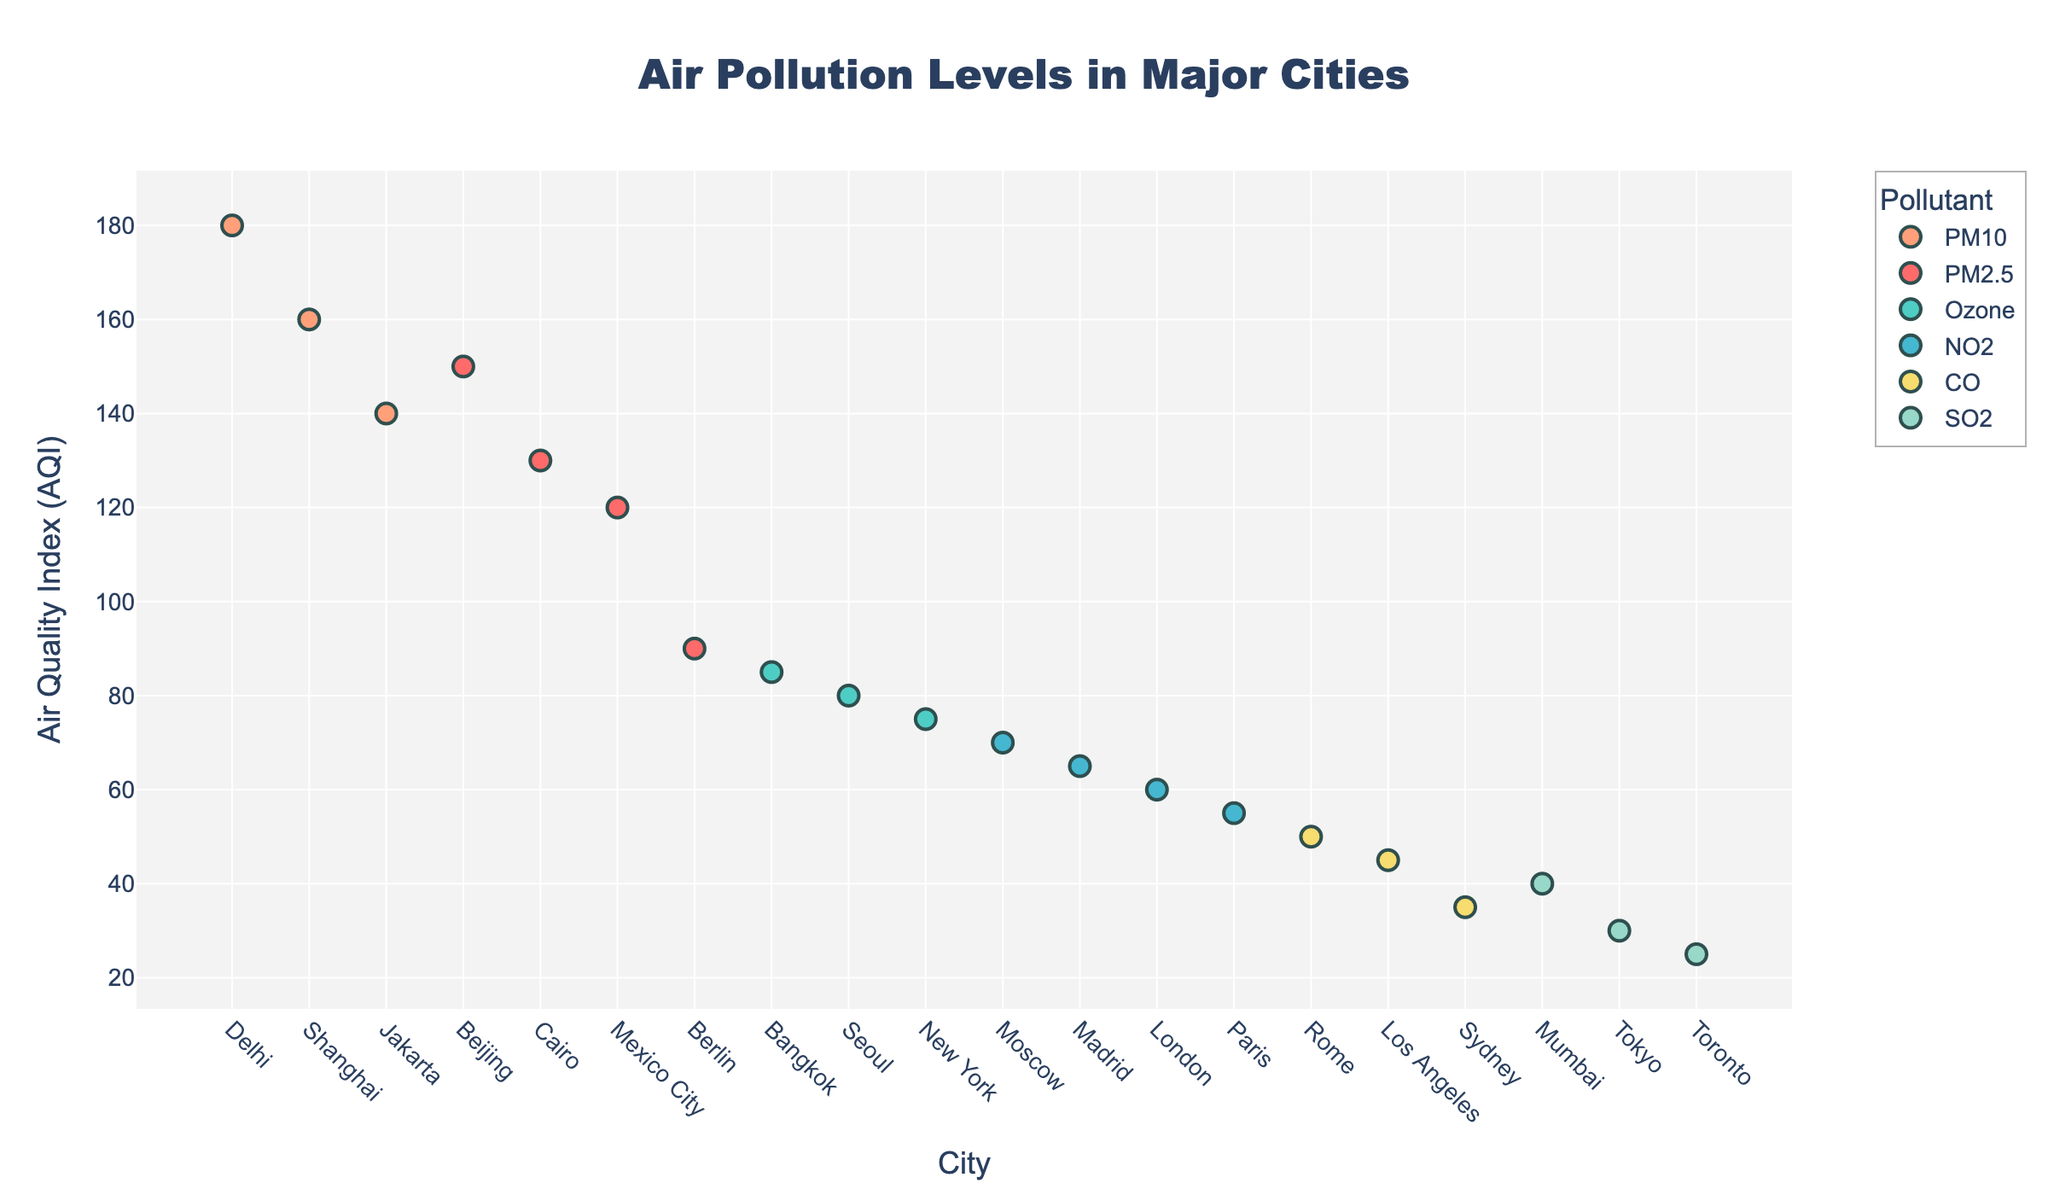What is the title of the plot? The title is displayed at the top of the figure, which summarizes the content of the plot.
Answer: Air Pollution Levels in Major Cities Which city has the highest AQI value and what is the pollutant? To find the city with the highest AQI value, look at the city with the highest point on the y-axis. Check the label or the legend to identify the pollutant.
Answer: Delhi, PM10 How many cities have AQI values greater than 100? Count the number of data points that are positioned above the 100 mark on the y-axis.
Answer: 6 Which pollutant has the widest range of AQI values across different cities? For each pollutant, observe the spread of values across the y-axis. The pollutant with the largest difference between the highest and lowest points is the one with the widest range.
Answer: PM2.5 Is there any city from Australia in the dataset, and what is its AQI value and pollutant type? Look for Sydney on the x-axis and check its corresponding y-axis value and the legend for the pollutant type.
Answer: Yes, Sydney, 35, CO Which pollutant type appears most frequently in this plot? Count the number of data points for each pollutant using the colors as a guide.
Answer: NO2 What is the average AQI value for cities with SO2 pollution? Find all the cities with SO2 pollution, sum their AQI values, and divide by the number of these cities. Cities: Tokyo (30), Mumbai (40), Toronto (25). Sum = 95, Average = 95/3 = 31.67.
Answer: 31.67 Compare the AQI value for New York and Los Angeles; which city has a higher value? Look at the y-axis values for New York and Los Angeles and compare them. New York has an AQI of 75, and Los Angeles has an AQI of 45.
Answer: New York Which pollutant type has the lowest AQI, and what is its value? Identify the point with the lowest y-axis value and check the legend to determine the pollutant type and its AQI value.
Answer: SO2, 25 What is the median AQI value for all cities displayed in the plot? Sort all AQI values and find the middle value. Sorted values: 25, 30, 35, 40, 45, 50, 55, 60, 65, 70, 75, 80, 85, 90, 120, 130, 140, 150, 160, 180. Median = (70 + 75) / 2 = 72.5
Answer: 72.5 